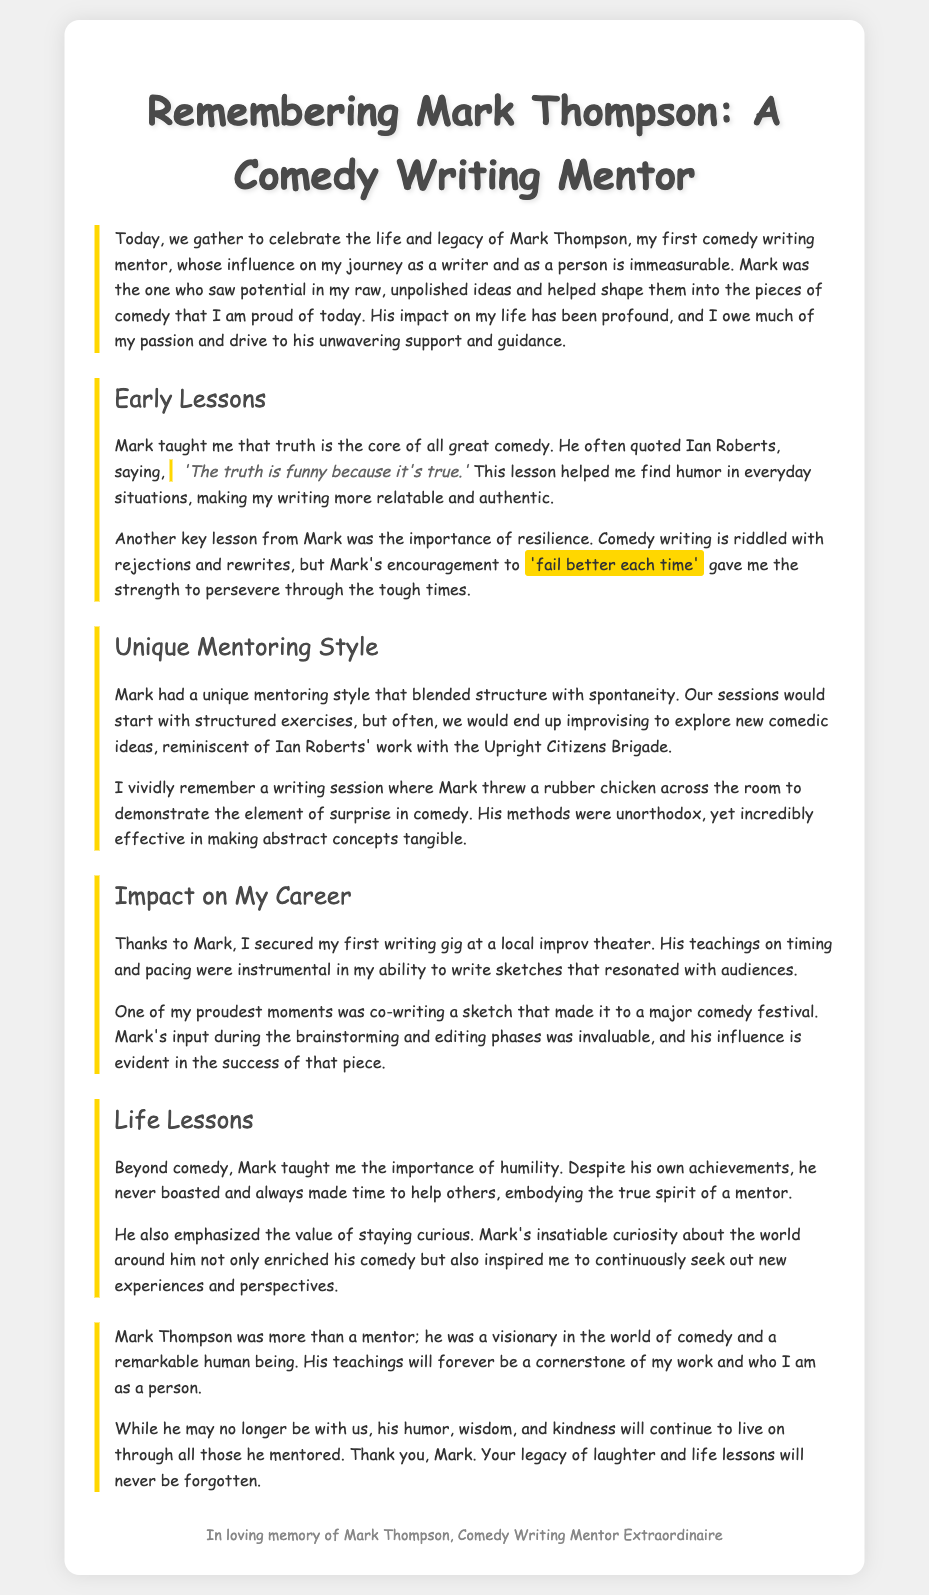What is the name of the mentor being remembered? The eulogy specifically mentions Mark Thompson as the comedy writing mentor.
Answer: Mark Thompson What quote from Ian Roberts is mentioned? The document cites a quote saying "The truth is funny because it's true," which emphasizes the comedic principle of truth.
Answer: The truth is funny because it's true What did Mark encourage when facing rejections? The eulogy mentions Mark's encouragement to "fail better each time" in the context of dealing with rejections.
Answer: Fail better each time What unique prop did Mark use in a session? The document recalls a session where Mark threw a rubber chicken to illustrate a comedic point.
Answer: Rubber chicken What was the writer's first gig attributed to Mark's teachings? The eulogy states that thanks to Mark, the writer secured their first writing gig at a local improv theater.
Answer: Local improv theater What was one of the writer's proudest moments? The writer describes co-writing a sketch that made it to a major comedy festival as a proud achievement.
Answer: Major comedy festival What did Mark emphasize about curiosity? Mark taught the importance of staying curious, which inspired the writer to seek new experiences.
Answer: Staying curious What type of legacy did Mark leave according to the eulogy? The writer reflects that Mark's humor, wisdom, and kindness will continue to live on through those he mentored.
Answer: Legacy of laughter and life lessons 